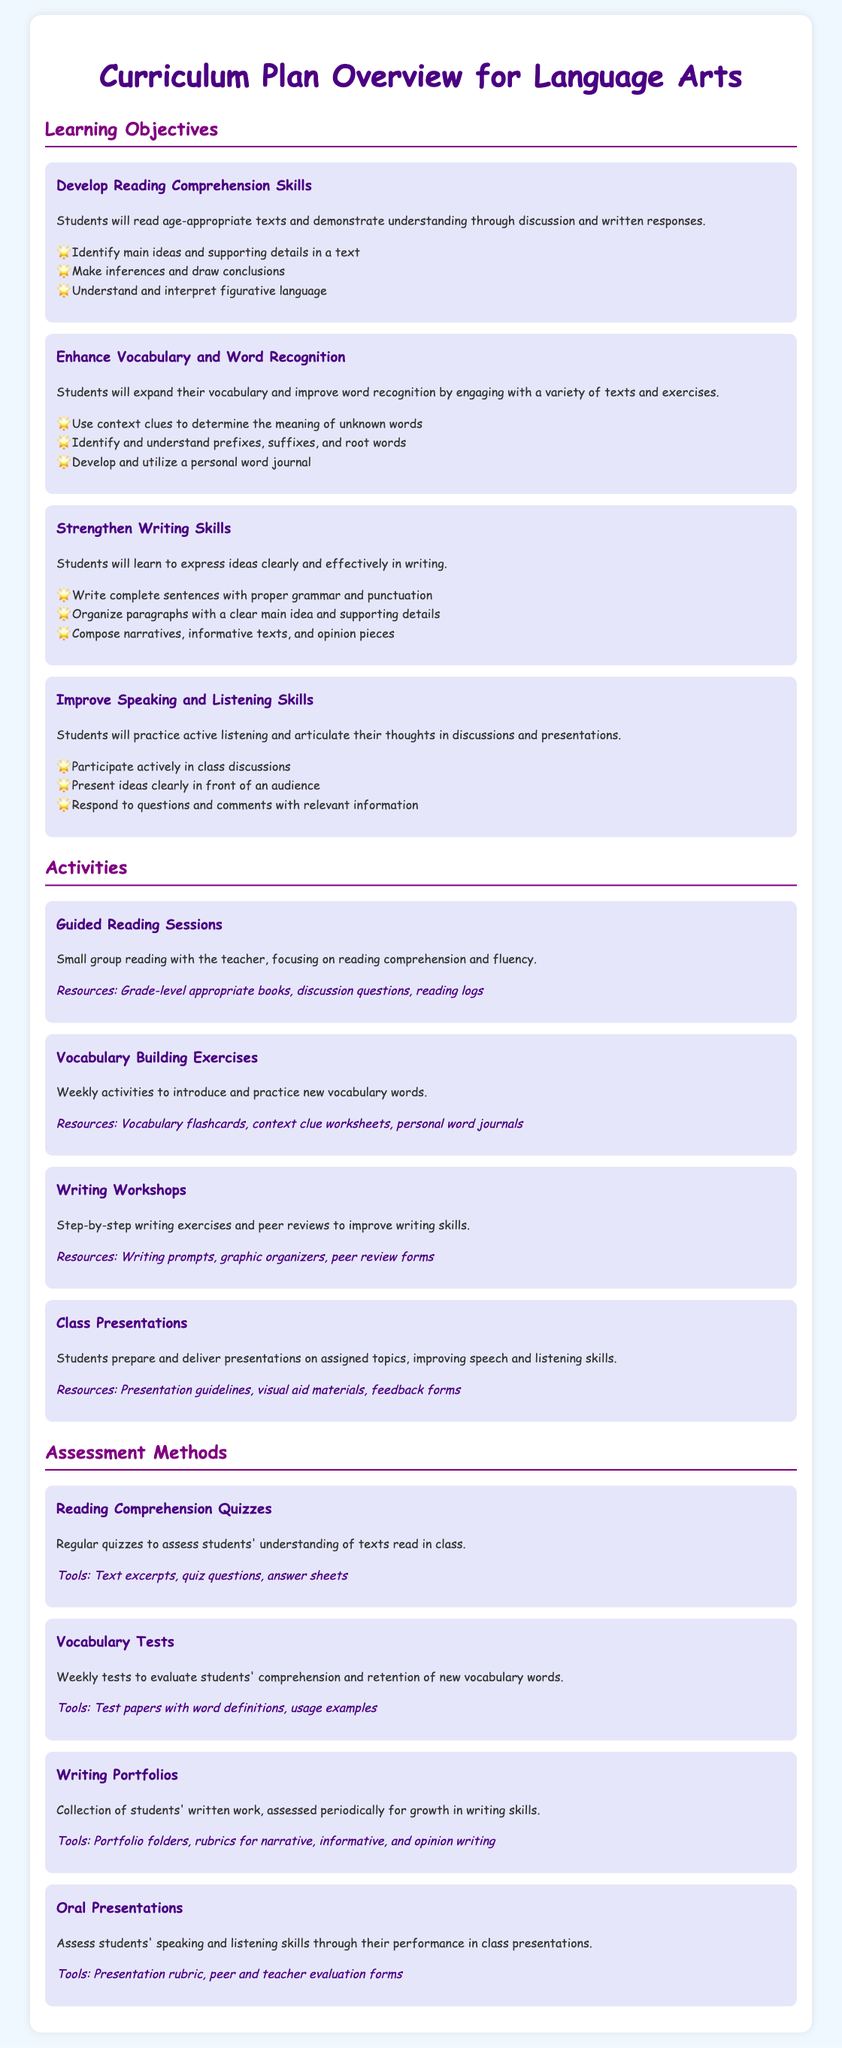What is the first learning objective? The first learning objective is listed at the beginning of the 'Learning Objectives' section, which is to develop reading comprehension skills.
Answer: Develop Reading Comprehension Skills How many writing skills are emphasized? The document lists three key skills under the writing objective, indicating the focus in this area.
Answer: Three What activity focuses on vocabulary building? The specific activity dedicated to vocabulary enhancement is detailed in the 'Activities' section, providing a clear focus on this area.
Answer: Vocabulary Building Exercises How are students assessed in reading comprehension? The assessment method for reading comprehension is highlighted in the 'Assessment Methods' section, specifying how understanding is evaluated.
Answer: Reading Comprehension Quizzes What tool is used for assessing writing skills? The document outlines various tools used for assessments, specifically noting one that aids in tracking writing progress.
Answer: Portfolio folders What is one method for improving speaking skills? One strategy mentioned for enhancing speaking skills involves delivering presentations, found under activities.
Answer: Class Presentations How many assessment methods are detailed? The total number of assessment methods can be counted from the section dedicated to assessment in the document.
Answer: Four What is the color theme of the document? The background and text colors, along with headings, suggest a specific color scheme throughout the document.
Answer: Light blue and purple What is included in the vocabulary building resources? One of the resources specified for vocabulary exercises is mentioned under the activities, giving insight into what materials are used.
Answer: Vocabulary flashcards 